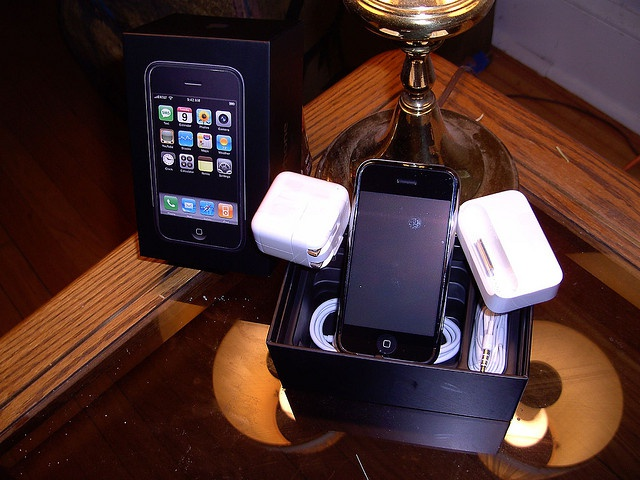Describe the objects in this image and their specific colors. I can see cell phone in black, navy, and purple tones and cell phone in black, navy, gray, and lavender tones in this image. 